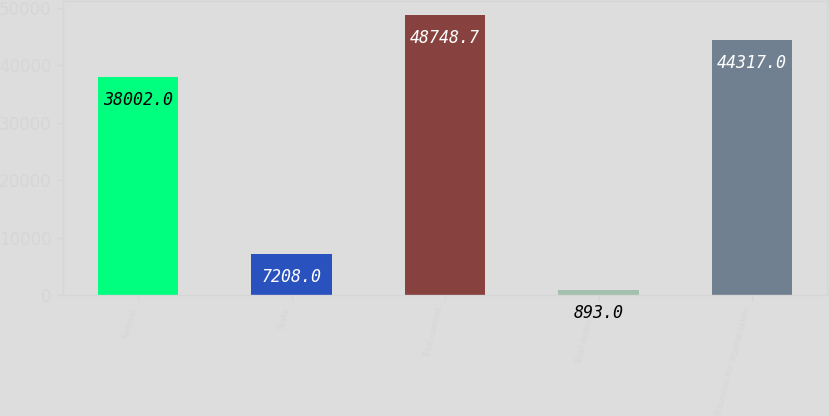<chart> <loc_0><loc_0><loc_500><loc_500><bar_chart><fcel>Federal<fcel>State<fcel>Total current<fcel>Total deferred<fcel>Provision for income taxes<nl><fcel>38002<fcel>7208<fcel>48748.7<fcel>893<fcel>44317<nl></chart> 